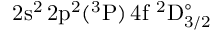Convert formula to latex. <formula><loc_0><loc_0><loc_500><loc_500>2 s ^ { 2 } \, 2 p ^ { 2 } ( ^ { 3 } P ) \, 4 f ^ { 2 } D _ { 3 / 2 } ^ { \circ }</formula> 